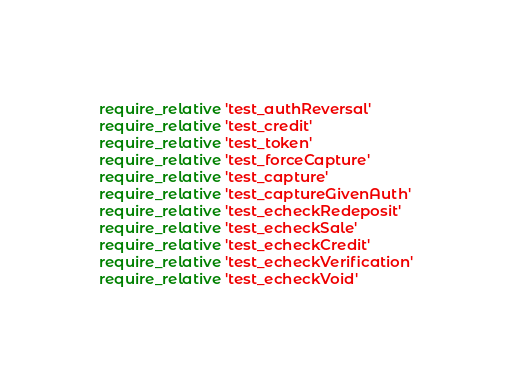<code> <loc_0><loc_0><loc_500><loc_500><_Ruby_>require_relative 'test_authReversal'
require_relative 'test_credit'
require_relative 'test_token'
require_relative 'test_forceCapture'
require_relative 'test_capture'
require_relative 'test_captureGivenAuth'
require_relative 'test_echeckRedeposit'
require_relative 'test_echeckSale'
require_relative 'test_echeckCredit'
require_relative 'test_echeckVerification'
require_relative 'test_echeckVoid'</code> 